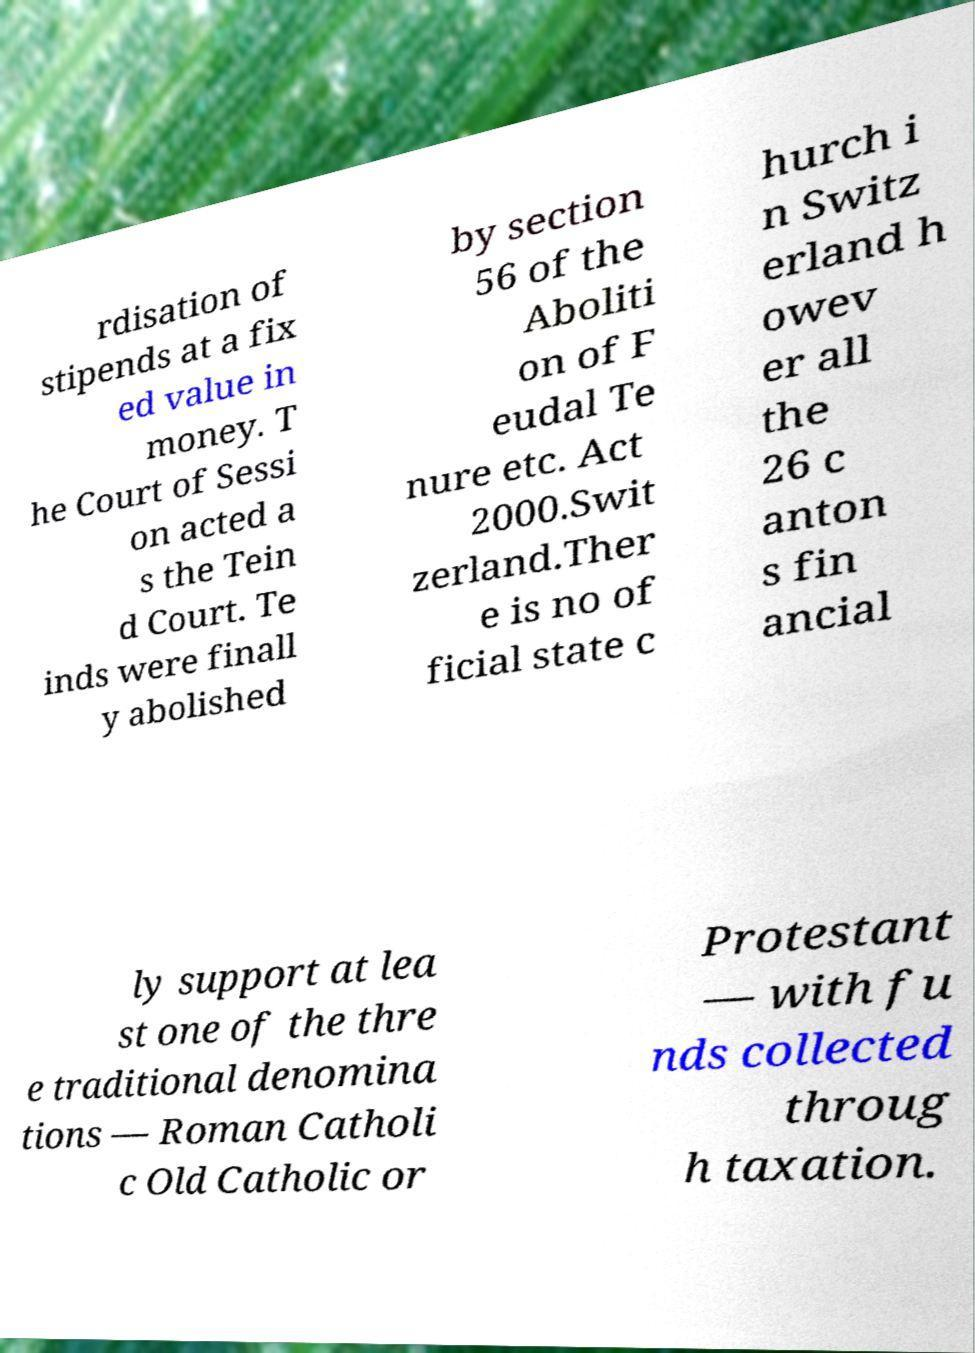I need the written content from this picture converted into text. Can you do that? rdisation of stipends at a fix ed value in money. T he Court of Sessi on acted a s the Tein d Court. Te inds were finall y abolished by section 56 of the Aboliti on of F eudal Te nure etc. Act 2000.Swit zerland.Ther e is no of ficial state c hurch i n Switz erland h owev er all the 26 c anton s fin ancial ly support at lea st one of the thre e traditional denomina tions — Roman Catholi c Old Catholic or Protestant — with fu nds collected throug h taxation. 